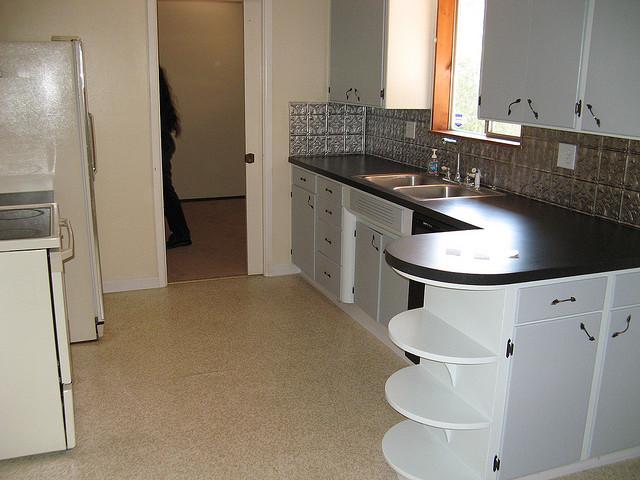Is this a modern kitchen?
Short answer required. No. What is the black splash made of?
Give a very brief answer. Tile. How many white shelves are in this kitchen?
Be succinct. 3. What type of room is shown?
Keep it brief. Kitchen. 